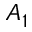Convert formula to latex. <formula><loc_0><loc_0><loc_500><loc_500>A _ { 1 }</formula> 